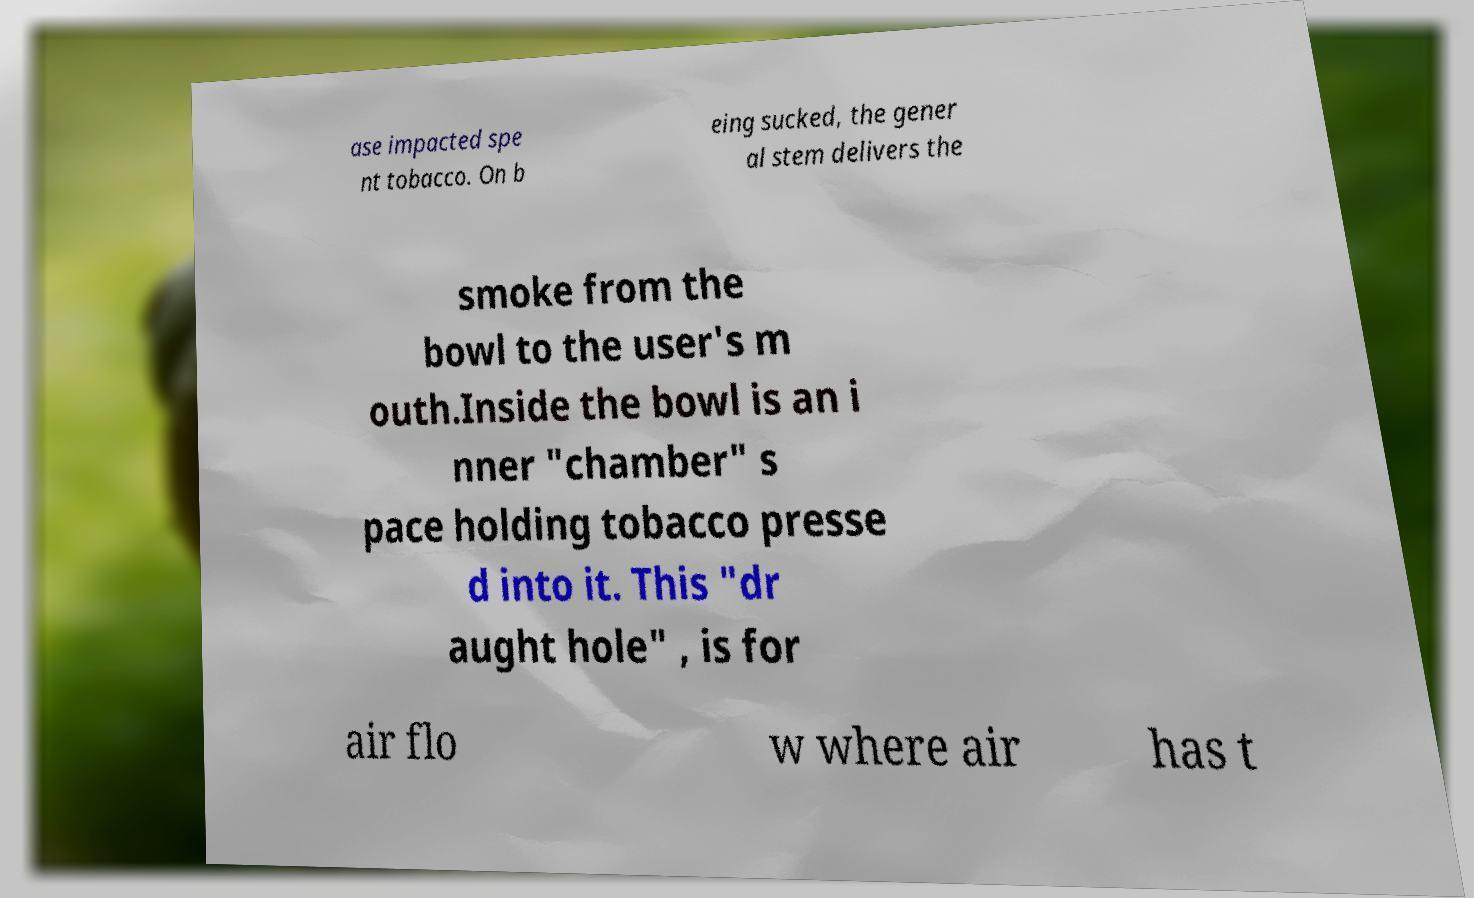There's text embedded in this image that I need extracted. Can you transcribe it verbatim? ase impacted spe nt tobacco. On b eing sucked, the gener al stem delivers the smoke from the bowl to the user's m outh.Inside the bowl is an i nner "chamber" s pace holding tobacco presse d into it. This "dr aught hole" , is for air flo w where air has t 